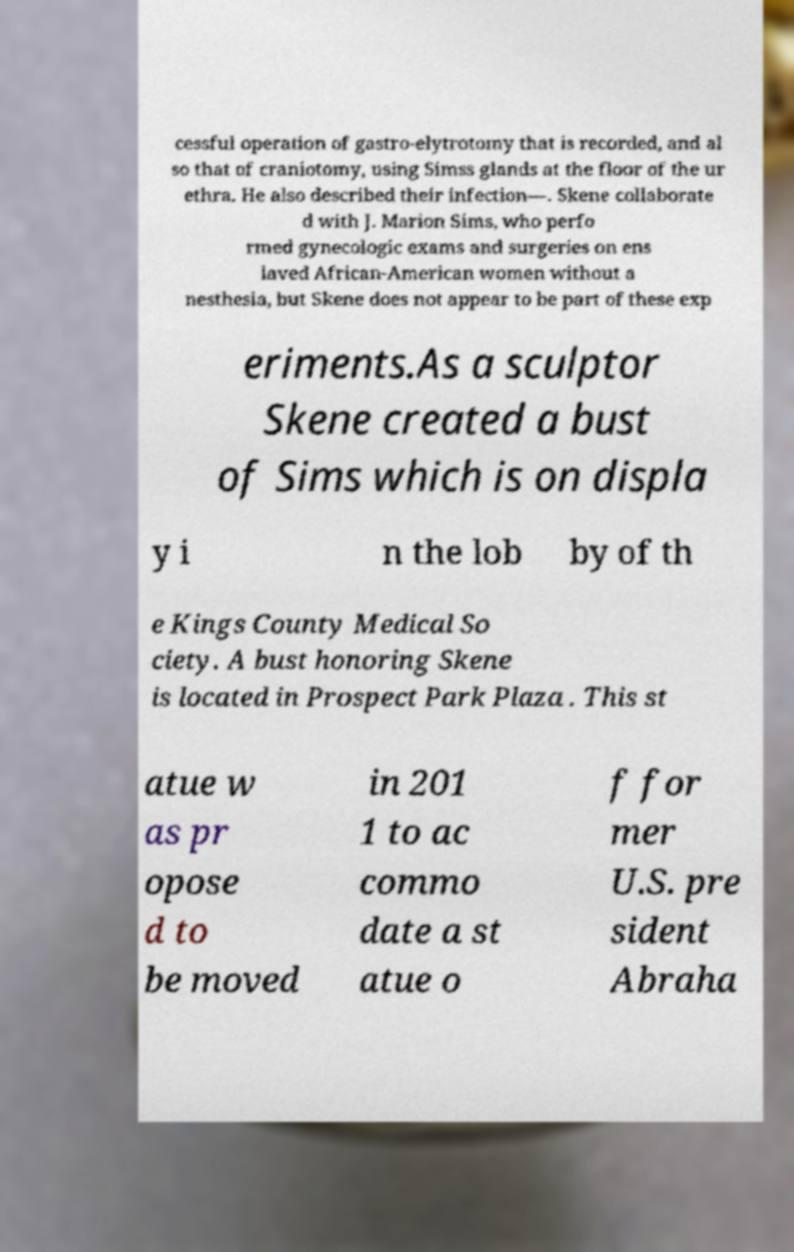For documentation purposes, I need the text within this image transcribed. Could you provide that? cessful operation of gastro-elytrotomy that is recorded, and al so that of craniotomy, using Simss glands at the floor of the ur ethra. He also described their infection—. Skene collaborate d with J. Marion Sims, who perfo rmed gynecologic exams and surgeries on ens laved African-American women without a nesthesia, but Skene does not appear to be part of these exp eriments.As a sculptor Skene created a bust of Sims which is on displa y i n the lob by of th e Kings County Medical So ciety. A bust honoring Skene is located in Prospect Park Plaza . This st atue w as pr opose d to be moved in 201 1 to ac commo date a st atue o f for mer U.S. pre sident Abraha 